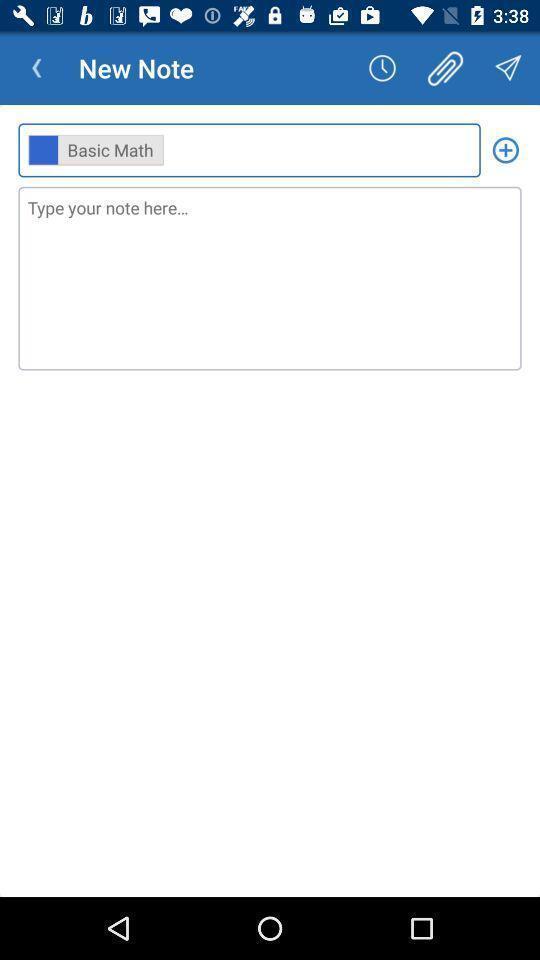Provide a detailed account of this screenshot. Screen showing new note page. 